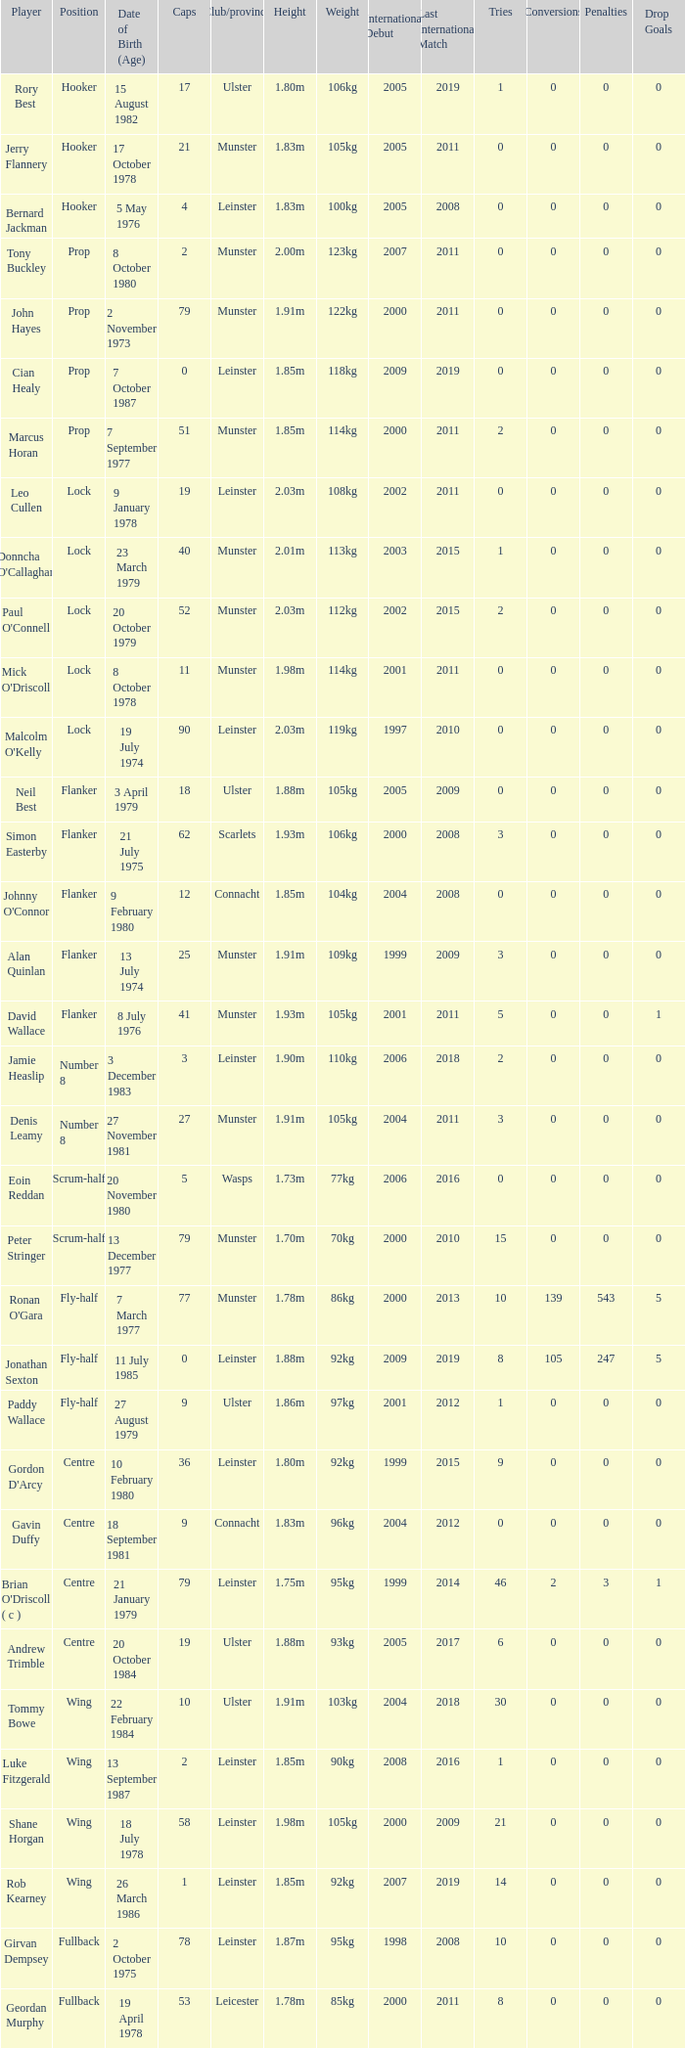Give me the full table as a dictionary. {'header': ['Player', 'Position', 'Date of Birth (Age)', 'Caps', 'Club/province', 'Height', 'Weight', 'International Debut', 'Last International Match', 'Tries', 'Conversions', 'Penalties', 'Drop Goals'], 'rows': [['Rory Best', 'Hooker', '15 August 1982', '17', 'Ulster', '1.80m', '106kg', '2005', '2019', '1', '0', '0', '0'], ['Jerry Flannery', 'Hooker', '17 October 1978', '21', 'Munster', '1.83m', '105kg', '2005', '2011', '0', '0', '0', '0'], ['Bernard Jackman', 'Hooker', '5 May 1976', '4', 'Leinster', '1.83m', '100kg', '2005', '2008', '0', '0', '0', '0'], ['Tony Buckley', 'Prop', '8 October 1980', '2', 'Munster', '2.00m', '123kg', '2007', '2011', '0', '0', '0', '0'], ['John Hayes', 'Prop', '2 November 1973', '79', 'Munster', '1.91m', '122kg', '2000', '2011', '0', '0', '0', '0'], ['Cian Healy', 'Prop', '7 October 1987', '0', 'Leinster', '1.85m', '118kg', '2009', '2019', '0', '0', '0', '0'], ['Marcus Horan', 'Prop', '7 September 1977', '51', 'Munster', '1.85m', '114kg', '2000', '2011', '2', '0', '0', '0'], ['Leo Cullen', 'Lock', '9 January 1978', '19', 'Leinster', '2.03m', '108kg', '2002', '2011', '0', '0', '0', '0'], ["Donncha O'Callaghan", 'Lock', '23 March 1979', '40', 'Munster', '2.01m', '113kg', '2003', '2015', '1', '0', '0', '0'], ["Paul O'Connell", 'Lock', '20 October 1979', '52', 'Munster', '2.03m', '112kg', '2002', '2015', '2', '0', '0', '0'], ["Mick O'Driscoll", 'Lock', '8 October 1978', '11', 'Munster', '1.98m', '114kg', '2001', '2011', '0', '0', '0', '0'], ["Malcolm O'Kelly", 'Lock', '19 July 1974', '90', 'Leinster', '2.03m', '119kg', '1997', '2010', '0', '0', '0', '0'], ['Neil Best', 'Flanker', '3 April 1979', '18', 'Ulster', '1.88m', '105kg', '2005', '2009', '0', '0', '0', '0'], ['Simon Easterby', 'Flanker', '21 July 1975', '62', 'Scarlets', '1.93m', '106kg', '2000', '2008', '3', '0', '0', '0'], ["Johnny O'Connor", 'Flanker', '9 February 1980', '12', 'Connacht', '1.85m', '104kg', '2004', '2008', '0', '0', '0', '0'], ['Alan Quinlan', 'Flanker', '13 July 1974', '25', 'Munster', '1.91m', '109kg', '1999', '2009', '3', '0', '0', '0'], ['David Wallace', 'Flanker', '8 July 1976', '41', 'Munster', '1.93m', '105kg', '2001', '2011', '5', '0', '0', '1'], ['Jamie Heaslip', 'Number 8', '3 December 1983', '3', 'Leinster', '1.90m', '110kg', '2006', '2018', '2', '0', '0', '0'], ['Denis Leamy', 'Number 8', '27 November 1981', '27', 'Munster', '1.91m', '105kg', '2004', '2011', '3', '0', '0', '0'], ['Eoin Reddan', 'Scrum-half', '20 November 1980', '5', 'Wasps', '1.73m', '77kg', '2006', '2016', '0', '0', '0', '0'], ['Peter Stringer', 'Scrum-half', '13 December 1977', '79', 'Munster', '1.70m', '70kg', '2000', '2010', '15', '0', '0', '0'], ["Ronan O'Gara", 'Fly-half', '7 March 1977', '77', 'Munster', '1.78m', '86kg', '2000', '2013', '10', '139', '543', '5'], ['Jonathan Sexton', 'Fly-half', '11 July 1985', '0', 'Leinster', '1.88m', '92kg', '2009', '2019', '8', '105', '247', '5'], ['Paddy Wallace', 'Fly-half', '27 August 1979', '9', 'Ulster', '1.86m', '97kg', '2001', '2012', '1', '0', '0', '0'], ["Gordon D'Arcy", 'Centre', '10 February 1980', '36', 'Leinster', '1.80m', '92kg', '1999', '2015', '9', '0', '0', '0'], ['Gavin Duffy', 'Centre', '18 September 1981', '9', 'Connacht', '1.83m', '96kg', '2004', '2012', '0', '0', '0', '0'], ["Brian O'Driscoll ( c )", 'Centre', '21 January 1979', '79', 'Leinster', '1.75m', '95kg', '1999', '2014', '46', '2', '3', '1'], ['Andrew Trimble', 'Centre', '20 October 1984', '19', 'Ulster', '1.88m', '93kg', '2005', '2017', '6', '0', '0', '0'], ['Tommy Bowe', 'Wing', '22 February 1984', '10', 'Ulster', '1.91m', '103kg', '2004', '2018', '30', '0', '0', '0'], ['Luke Fitzgerald', 'Wing', '13 September 1987', '2', 'Leinster', '1.85m', '90kg', '2008', '2016', '1', '0', '0', '0'], ['Shane Horgan', 'Wing', '18 July 1978', '58', 'Leinster', '1.98m', '105kg', '2000', '2009', '21', '0', '0', '0'], ['Rob Kearney', 'Wing', '26 March 1986', '1', 'Leinster', '1.85m', '92kg', '2007', '2019', '14', '0', '0', '0'], ['Girvan Dempsey', 'Fullback', '2 October 1975', '78', 'Leinster', '1.87m', '95kg', '1998', '2008', '10', '0', '0', '0'], ['Geordan Murphy', 'Fullback', '19 April 1978', '53', 'Leicester', '1.78m', '85kg', '2000', '2011', '8', '0', '0', '0']]} Paddy Wallace who plays the position of fly-half has how many Caps? 9.0. 